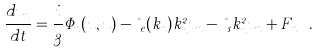<formula> <loc_0><loc_0><loc_500><loc_500>\frac { d u _ { n } } { d t } = \frac { i } { 3 } \Phi _ { n } ( u , u ) - \nu _ { e } ( k _ { n } ) k _ { n } ^ { 2 } u _ { n } - \nu _ { s } k ^ { 2 } _ { n } u _ { n } + F _ { n } \ .</formula> 